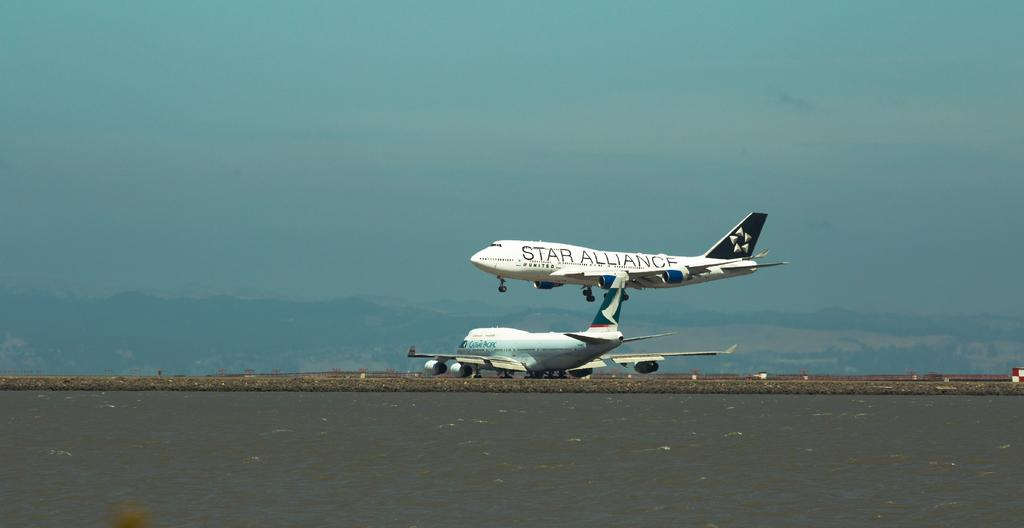<image>
Write a terse but informative summary of the picture. A Star Alliance airplane is up up in the air above another plane that is on the ground. 